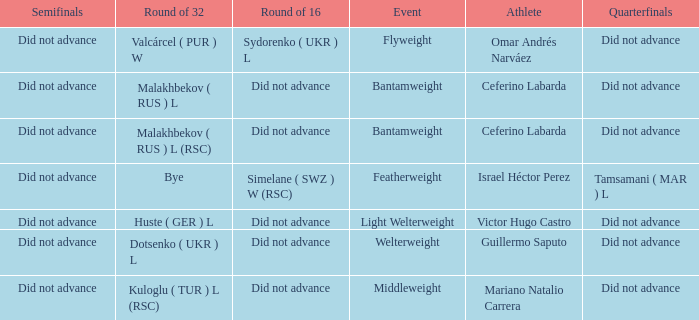When there was a bye in the round of 32, what was the result in the round of 16? Did not advance. 